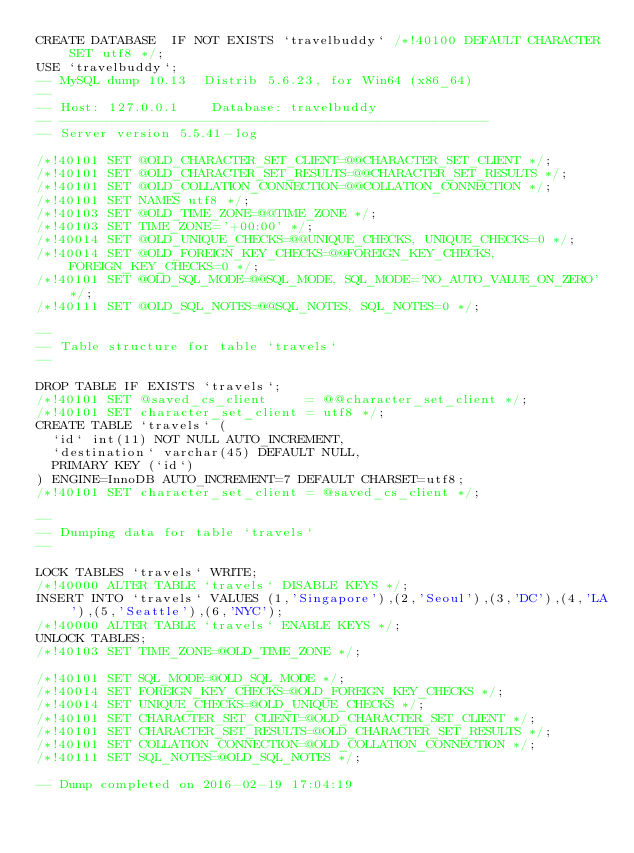<code> <loc_0><loc_0><loc_500><loc_500><_SQL_>CREATE DATABASE  IF NOT EXISTS `travelbuddy` /*!40100 DEFAULT CHARACTER SET utf8 */;
USE `travelbuddy`;
-- MySQL dump 10.13  Distrib 5.6.23, for Win64 (x86_64)
--
-- Host: 127.0.0.1    Database: travelbuddy
-- ------------------------------------------------------
-- Server version	5.5.41-log

/*!40101 SET @OLD_CHARACTER_SET_CLIENT=@@CHARACTER_SET_CLIENT */;
/*!40101 SET @OLD_CHARACTER_SET_RESULTS=@@CHARACTER_SET_RESULTS */;
/*!40101 SET @OLD_COLLATION_CONNECTION=@@COLLATION_CONNECTION */;
/*!40101 SET NAMES utf8 */;
/*!40103 SET @OLD_TIME_ZONE=@@TIME_ZONE */;
/*!40103 SET TIME_ZONE='+00:00' */;
/*!40014 SET @OLD_UNIQUE_CHECKS=@@UNIQUE_CHECKS, UNIQUE_CHECKS=0 */;
/*!40014 SET @OLD_FOREIGN_KEY_CHECKS=@@FOREIGN_KEY_CHECKS, FOREIGN_KEY_CHECKS=0 */;
/*!40101 SET @OLD_SQL_MODE=@@SQL_MODE, SQL_MODE='NO_AUTO_VALUE_ON_ZERO' */;
/*!40111 SET @OLD_SQL_NOTES=@@SQL_NOTES, SQL_NOTES=0 */;

--
-- Table structure for table `travels`
--

DROP TABLE IF EXISTS `travels`;
/*!40101 SET @saved_cs_client     = @@character_set_client */;
/*!40101 SET character_set_client = utf8 */;
CREATE TABLE `travels` (
  `id` int(11) NOT NULL AUTO_INCREMENT,
  `destination` varchar(45) DEFAULT NULL,
  PRIMARY KEY (`id`)
) ENGINE=InnoDB AUTO_INCREMENT=7 DEFAULT CHARSET=utf8;
/*!40101 SET character_set_client = @saved_cs_client */;

--
-- Dumping data for table `travels`
--

LOCK TABLES `travels` WRITE;
/*!40000 ALTER TABLE `travels` DISABLE KEYS */;
INSERT INTO `travels` VALUES (1,'Singapore'),(2,'Seoul'),(3,'DC'),(4,'LA'),(5,'Seattle'),(6,'NYC');
/*!40000 ALTER TABLE `travels` ENABLE KEYS */;
UNLOCK TABLES;
/*!40103 SET TIME_ZONE=@OLD_TIME_ZONE */;

/*!40101 SET SQL_MODE=@OLD_SQL_MODE */;
/*!40014 SET FOREIGN_KEY_CHECKS=@OLD_FOREIGN_KEY_CHECKS */;
/*!40014 SET UNIQUE_CHECKS=@OLD_UNIQUE_CHECKS */;
/*!40101 SET CHARACTER_SET_CLIENT=@OLD_CHARACTER_SET_CLIENT */;
/*!40101 SET CHARACTER_SET_RESULTS=@OLD_CHARACTER_SET_RESULTS */;
/*!40101 SET COLLATION_CONNECTION=@OLD_COLLATION_CONNECTION */;
/*!40111 SET SQL_NOTES=@OLD_SQL_NOTES */;

-- Dump completed on 2016-02-19 17:04:19
</code> 